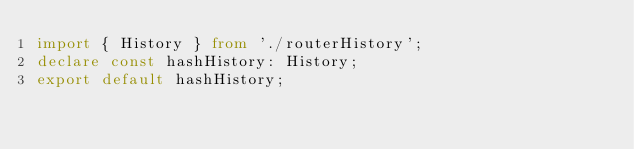Convert code to text. <code><loc_0><loc_0><loc_500><loc_500><_TypeScript_>import { History } from './routerHistory';
declare const hashHistory: History;
export default hashHistory;
</code> 